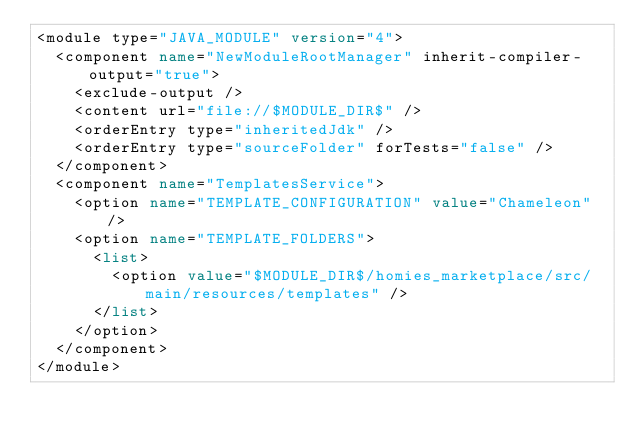Convert code to text. <code><loc_0><loc_0><loc_500><loc_500><_XML_><module type="JAVA_MODULE" version="4">
  <component name="NewModuleRootManager" inherit-compiler-output="true">
    <exclude-output />
    <content url="file://$MODULE_DIR$" />
    <orderEntry type="inheritedJdk" />
    <orderEntry type="sourceFolder" forTests="false" />
  </component>
  <component name="TemplatesService">
    <option name="TEMPLATE_CONFIGURATION" value="Chameleon" />
    <option name="TEMPLATE_FOLDERS">
      <list>
        <option value="$MODULE_DIR$/homies_marketplace/src/main/resources/templates" />
      </list>
    </option>
  </component>
</module></code> 